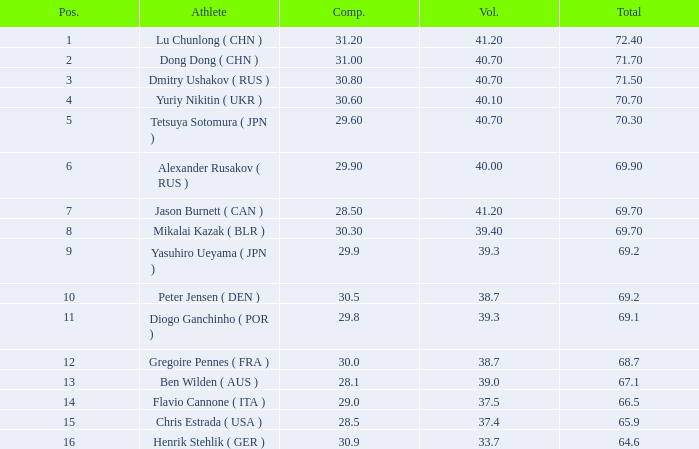What's the total compulsory when the total is more than 69.2 and the voluntary is 38.7? 0.0. 